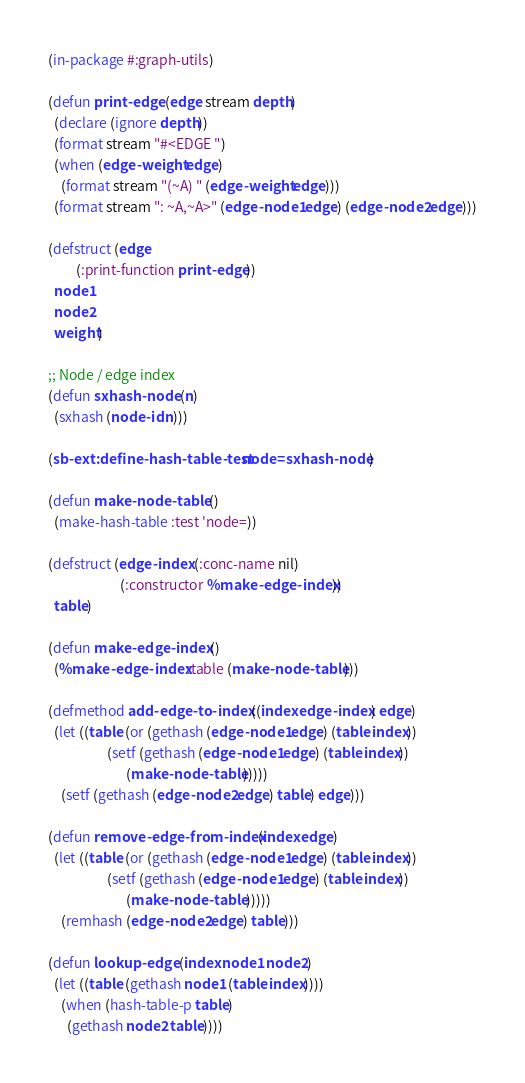<code> <loc_0><loc_0><loc_500><loc_500><_Lisp_>(in-package #:graph-utils)

(defun print-edge (edge stream depth)
  (declare (ignore depth))
  (format stream "#<EDGE ")
  (when (edge-weight edge)
    (format stream "(~A) " (edge-weight edge)))
  (format stream ": ~A,~A>" (edge-node1 edge) (edge-node2 edge)))

(defstruct (edge
	     (:print-function print-edge))
  node1
  node2
  weight)

;; Node / edge index
(defun sxhash-node (n)
  (sxhash (node-id n)))

(sb-ext:define-hash-table-test node= sxhash-node)

(defun make-node-table ()
  (make-hash-table :test 'node=))

(defstruct (edge-index (:conc-name nil)
                       (:constructor %make-edge-index))
  table)

(defun make-edge-index ()
  (%make-edge-index :table (make-node-table)))

(defmethod add-edge-to-index ((index edge-index) edge)
  (let ((table (or (gethash (edge-node1 edge) (table index))
                   (setf (gethash (edge-node1 edge) (table index))
                         (make-node-table)))))
    (setf (gethash (edge-node2 edge) table) edge)))

(defun remove-edge-from-index (index edge)
  (let ((table (or (gethash (edge-node1 edge) (table index))
                   (setf (gethash (edge-node1 edge) (table index))
                         (make-node-table )))))
    (remhash (edge-node2 edge) table)))

(defun lookup-edge (index node1 node2)
  (let ((table (gethash node1 (table index))))
    (when (hash-table-p table)
      (gethash node2 table))))

</code> 